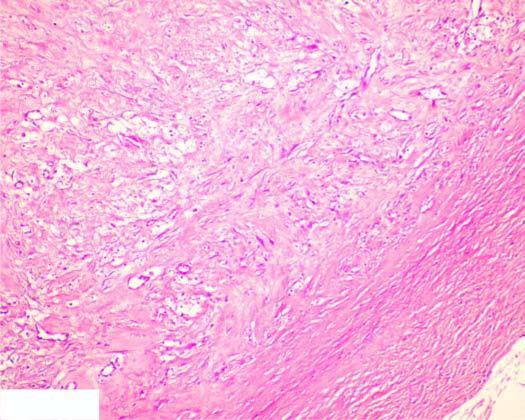what is the circumscribed lesion composed of?
Answer the question using a single word or phrase. Mature collagenised fibrous connective tissue 